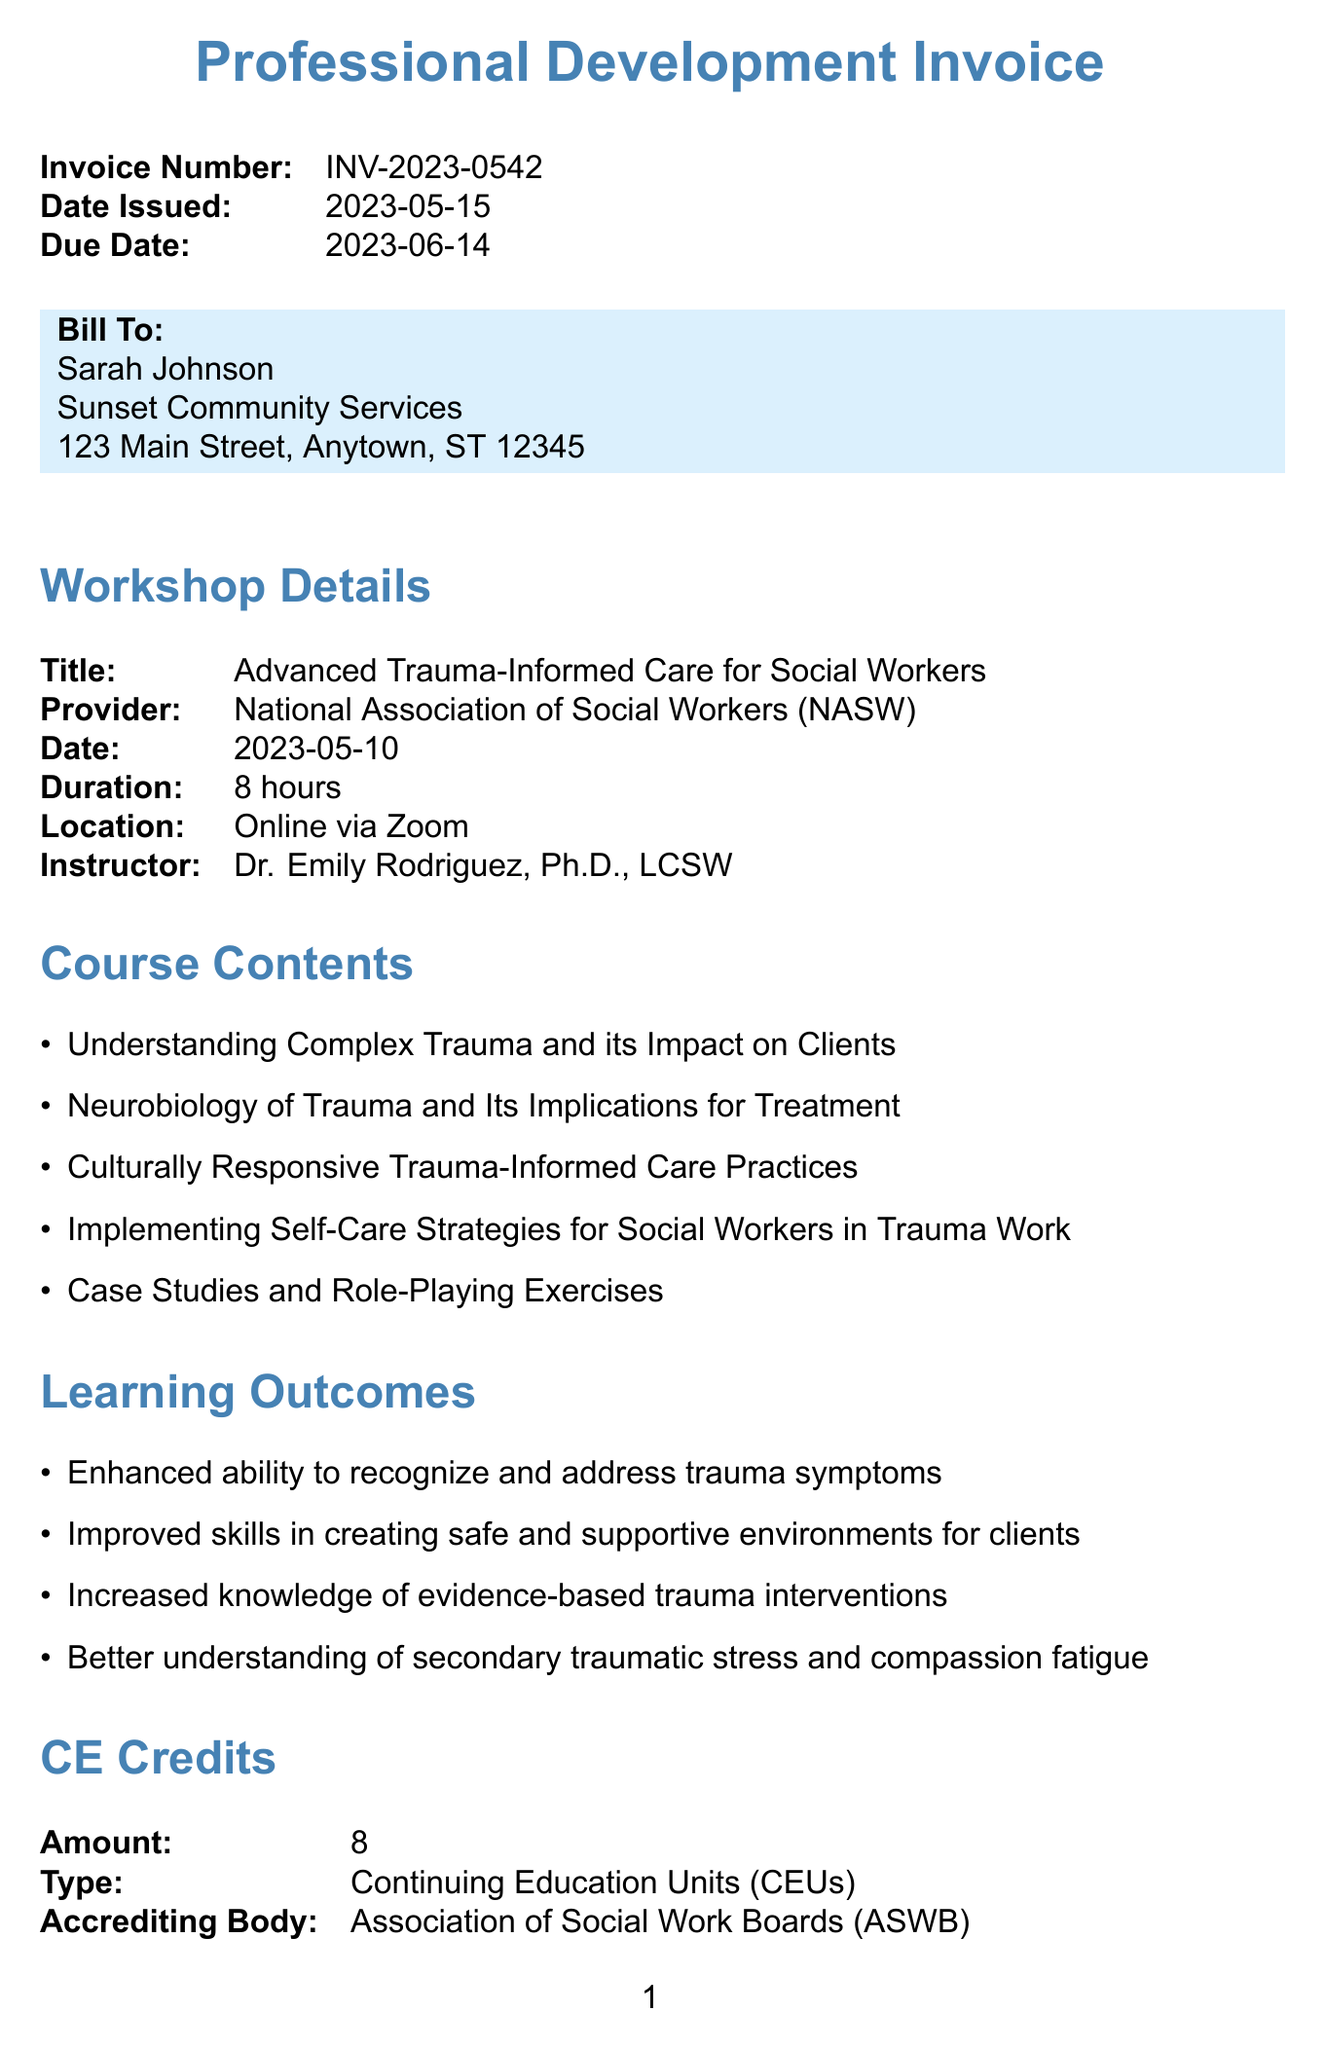What is the invoice number? The invoice number is a unique identifier for the document which can be found in the invoice details section.
Answer: INV-2023-0542 What is the date of the workshop? The date of the workshop is provided in the workshop details section of the document.
Answer: 2023-05-10 Who is the instructor of the workshop? The instructor's name is listed in the workshop details section, which indicates the person responsible for teaching the course.
Answer: Dr. Emily Rodriguez, Ph.D., LCSW What is the total amount due? The total amount due is calculated from the itemized costs in the invoice.
Answer: $339.00 How many Continuing Education Units (CEUs) are awarded? The number of CEUs is specified in the CE credits section of the document.
Answer: 8 What type of payment methods are accepted? The accepted payment methods can be found in the payment methods section of the invoice.
Answer: Credit Card, PayPal, Bank Transfer What is the main focus of the workshop content? The main focus can be inferred from the course contents which emphasize trauma-informed care practices and strategies.
Answer: Trauma-informed care What organization provides the workshop? The provider details are specified in the workshop section, identifying who offers the training.
Answer: National Association of Social Workers (NASW) What is one learning outcome of the workshop? Learning outcomes are listed in the document and emphasize skills gained from the workshop.
Answer: Enhanced ability to recognize and address trauma symptoms 